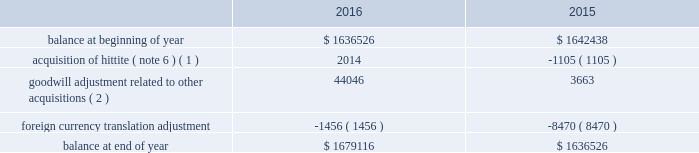Analog devices , inc .
Notes to consolidated financial statements 2014 ( continued ) depreciation expense for property , plant and equipment was $ 134.5 million , $ 130.1 million and $ 114.1 million in fiscal 2016 , 2015 and 2014 , respectively .
The company reviews property , plant and equipment for impairment whenever events or changes in circumstances indicate that the carrying amount of assets may not be recoverable .
Recoverability of these assets is determined by comparison of their carrying amount to the future undiscounted cash flows the assets are expected to generate over their remaining economic lives .
If such assets are considered to be impaired , the impairment to be recognized in earnings equals the amount by which the carrying value of the assets exceeds their fair value determined by either a quoted market price , if any , or a value determined by utilizing a discounted cash flow technique .
If such assets are not impaired , but their useful lives have decreased , the remaining net book value is depreciated over the revised useful life .
We have not recorded any material impairment charges related to our property , plant and equipment in fiscal 2016 , fiscal 2015 or fiscal 2014 .
Goodwill and intangible assets goodwill the company evaluates goodwill for impairment annually , as well as whenever events or changes in circumstances suggest that the carrying value of goodwill may not be recoverable .
The company tests goodwill for impairment at the reporting unit level ( operating segment or one level below an operating segment ) on an annual basis on the first day of the fourth quarter ( on or about august 1 ) or more frequently if indicators of impairment exist .
For the company 2019s latest annual impairment assessment that occurred as of july 31 , 2016 , the company identified its reporting units to be its seven operating segments .
The performance of the test involves a two-step process .
The first step of the quantitative impairment test involves comparing the fair values of the applicable reporting units with their aggregate carrying values , including goodwill .
The company determines the fair value of its reporting units using a weighting of the income and market approaches .
Under the income approach , the company uses a discounted cash flow methodology which requires management to make significant estimates and assumptions related to forecasted revenues , gross profit margins , operating income margins , working capital cash flow , perpetual growth rates , and long-term discount rates , among others .
For the market approach , the company uses the guideline public company method .
Under this method the company utilizes information from comparable publicly traded companies with similar operating and investment characteristics as the reporting units , to create valuation multiples that are applied to the operating performance of the reporting unit being tested , in order to obtain their respective fair values .
In order to assess the reasonableness of the calculated reporting unit fair values , the company reconciles the aggregate fair values of its reporting units determined , as described above , to its current market capitalization , allowing for a reasonable control premium .
If the carrying amount of a reporting unit , calculated using the above approaches , exceeds the reporting unit 2019s fair value , the company performs the second step of the goodwill impairment test to determine the amount of impairment loss .
The second step of the goodwill impairment test involves comparing the implied fair value of the affected reporting unit 2019s goodwill with the carrying value of that reporting unit .
There was no impairment of goodwill in any of the fiscal years presented .
The company 2019s next annual impairment assessment will be performed as of the first day of the fourth quarter of the fiscal year ending october 28 , 2017 ( fiscal 2017 ) unless indicators arise that would require the company to reevaluate at an earlier date .
The table presents the changes in goodwill during fiscal 2016 and fiscal 2015: .
( 1 ) amount in fiscal 2015 represents changes to goodwill as a result of finalizing the acquisition accounting related to the hittite acquisition .
( 2 ) represents goodwill related to other acquisitions that were not material to the company on either an individual or aggregate basis .
Intangible assets the company reviews finite-lived intangible assets for impairment whenever events or changes in circumstances indicate that the carrying value of assets may not be recoverable .
Recoverability of these assets is determined by comparison of their carrying value to the estimated future undiscounted cash flows the assets are expected to generate over their remaining .
What is the percentage change in the balance of goodwill from 2015 to 2016? 
Computations: ((1679116 - 1636526) / 1636526)
Answer: 0.02602. 